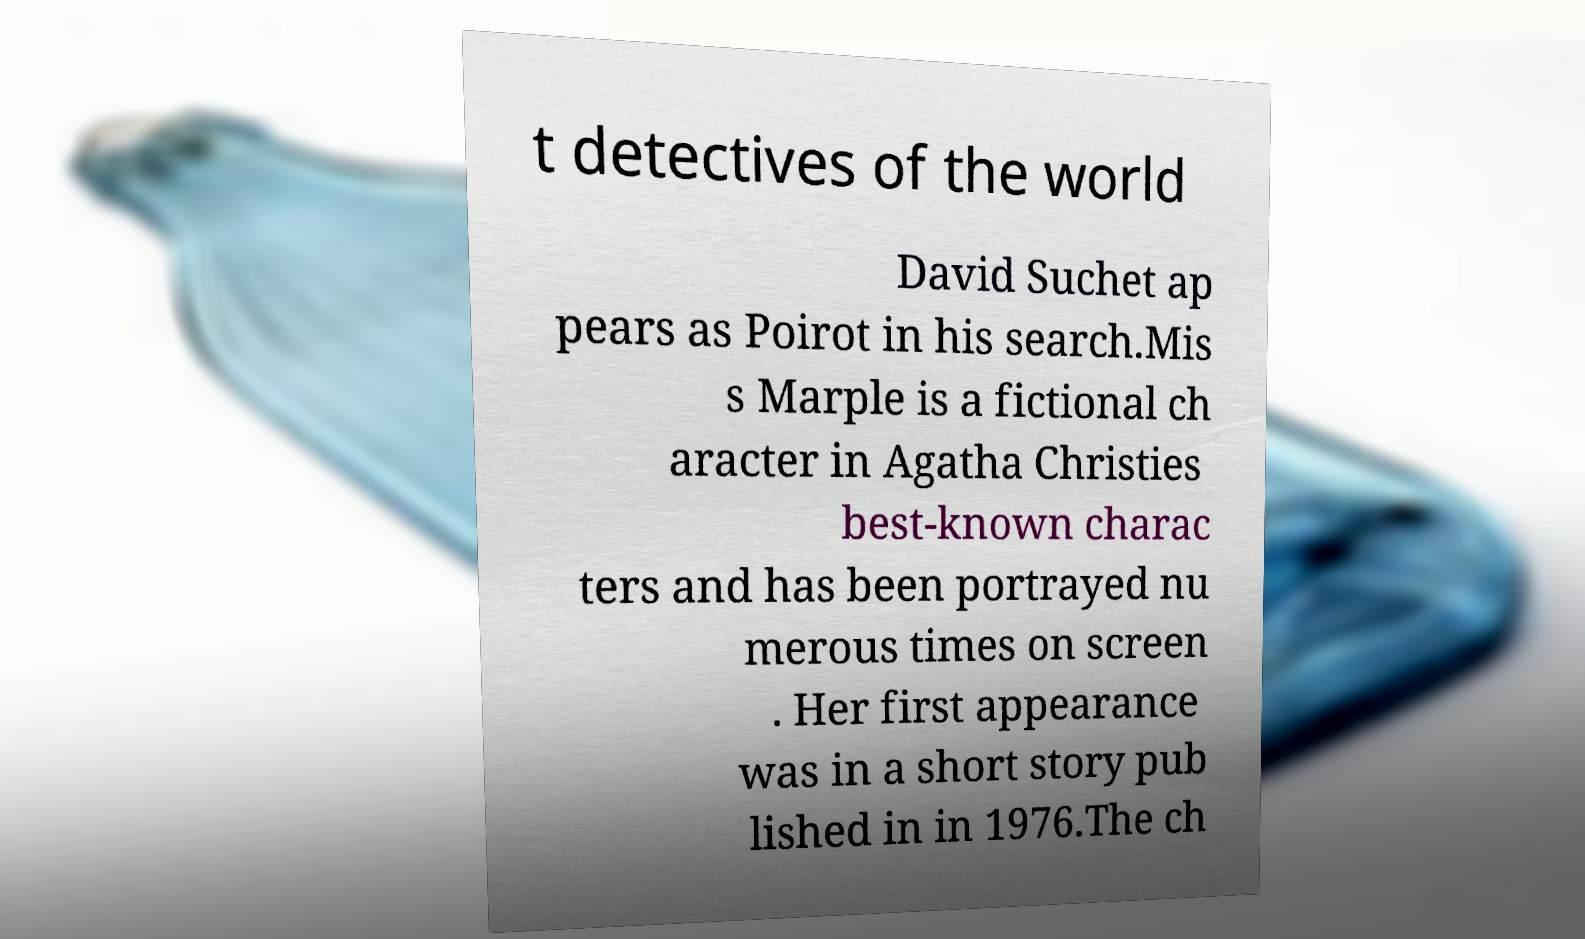I need the written content from this picture converted into text. Can you do that? t detectives of the world David Suchet ap pears as Poirot in his search.Mis s Marple is a fictional ch aracter in Agatha Christies best-known charac ters and has been portrayed nu merous times on screen . Her first appearance was in a short story pub lished in in 1976.The ch 